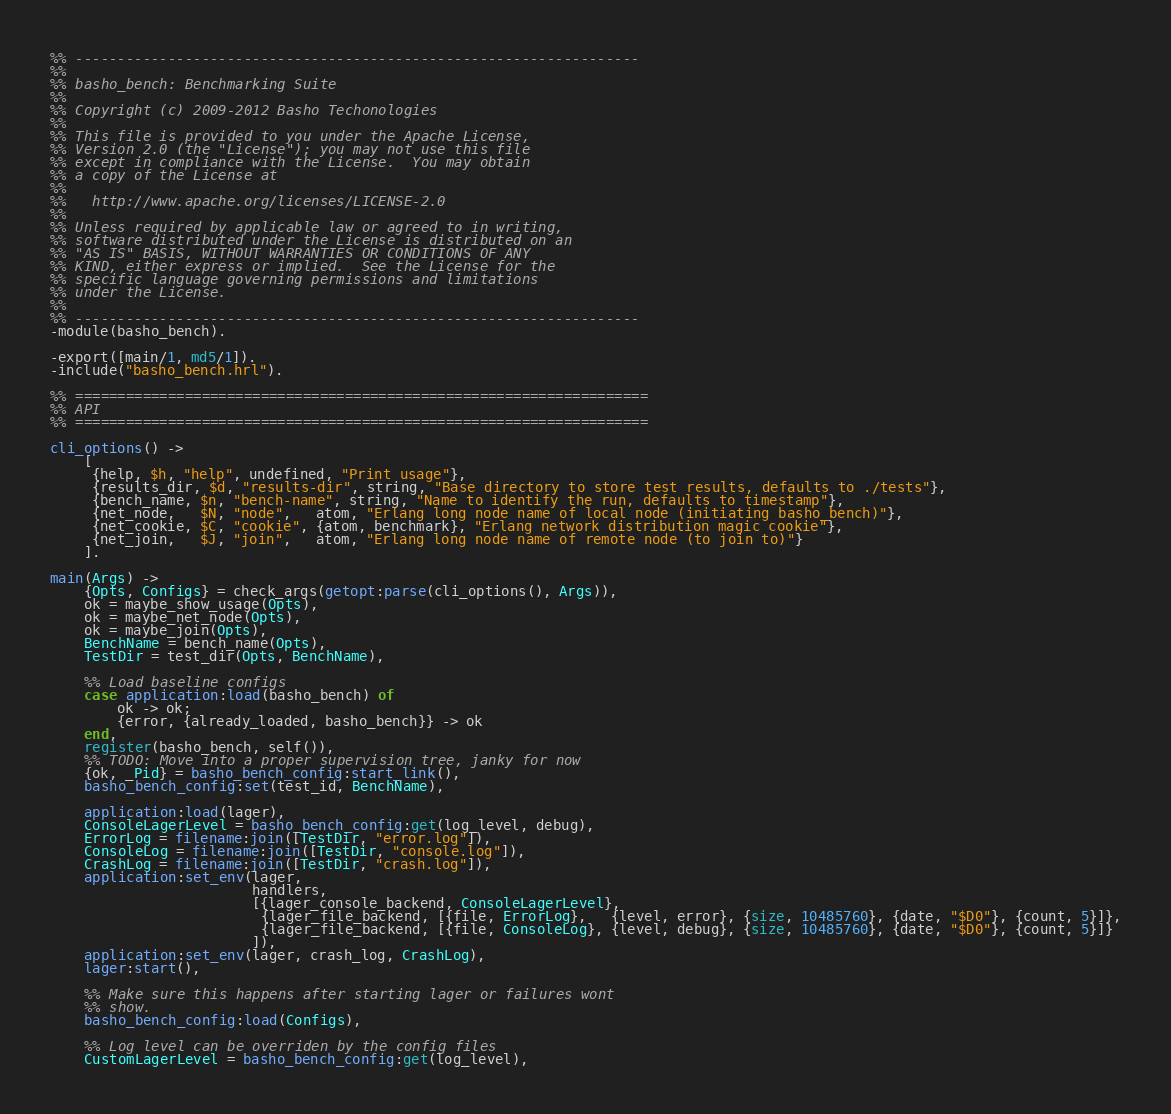Convert code to text. <code><loc_0><loc_0><loc_500><loc_500><_Erlang_>%% -------------------------------------------------------------------
%%
%% basho_bench: Benchmarking Suite
%%
%% Copyright (c) 2009-2012 Basho Techonologies
%%
%% This file is provided to you under the Apache License,
%% Version 2.0 (the "License"); you may not use this file
%% except in compliance with the License.  You may obtain
%% a copy of the License at
%%
%%   http://www.apache.org/licenses/LICENSE-2.0
%%
%% Unless required by applicable law or agreed to in writing,
%% software distributed under the License is distributed on an
%% "AS IS" BASIS, WITHOUT WARRANTIES OR CONDITIONS OF ANY
%% KIND, either express or implied.  See the License for the
%% specific language governing permissions and limitations
%% under the License.
%%
%% -------------------------------------------------------------------
-module(basho_bench).

-export([main/1, md5/1]).
-include("basho_bench.hrl").

%% ====================================================================
%% API
%% ====================================================================

cli_options() ->
    [
     {help, $h, "help", undefined, "Print usage"},
     {results_dir, $d, "results-dir", string, "Base directory to store test results, defaults to ./tests"},
     {bench_name, $n, "bench-name", string, "Name to identify the run, defaults to timestamp"},
     {net_node,   $N, "node",   atom, "Erlang long node name of local node (initiating basho_bench)"},
     {net_cookie, $C, "cookie", {atom, benchmark}, "Erlang network distribution magic cookie"},
     {net_join,   $J, "join",   atom, "Erlang long node name of remote node (to join to)"}
    ].

main(Args) ->
    {Opts, Configs} = check_args(getopt:parse(cli_options(), Args)),
    ok = maybe_show_usage(Opts),
    ok = maybe_net_node(Opts),
    ok = maybe_join(Opts),
    BenchName = bench_name(Opts),
    TestDir = test_dir(Opts, BenchName),

    %% Load baseline configs
    case application:load(basho_bench) of
        ok -> ok;
        {error, {already_loaded, basho_bench}} -> ok
    end,
    register(basho_bench, self()),
    %% TODO: Move into a proper supervision tree, janky for now
    {ok, _Pid} = basho_bench_config:start_link(),
    basho_bench_config:set(test_id, BenchName),

    application:load(lager),
    ConsoleLagerLevel = basho_bench_config:get(log_level, debug),
    ErrorLog = filename:join([TestDir, "error.log"]),
    ConsoleLog = filename:join([TestDir, "console.log"]),
    CrashLog = filename:join([TestDir, "crash.log"]),
    application:set_env(lager,
                        handlers,
                        [{lager_console_backend, ConsoleLagerLevel},
                         {lager_file_backend, [{file, ErrorLog},   {level, error}, {size, 10485760}, {date, "$D0"}, {count, 5}]},
                         {lager_file_backend, [{file, ConsoleLog}, {level, debug}, {size, 10485760}, {date, "$D0"}, {count, 5}]}
                        ]),
    application:set_env(lager, crash_log, CrashLog),
    lager:start(),

    %% Make sure this happens after starting lager or failures wont
    %% show.
    basho_bench_config:load(Configs),

    %% Log level can be overriden by the config files
    CustomLagerLevel = basho_bench_config:get(log_level),</code> 